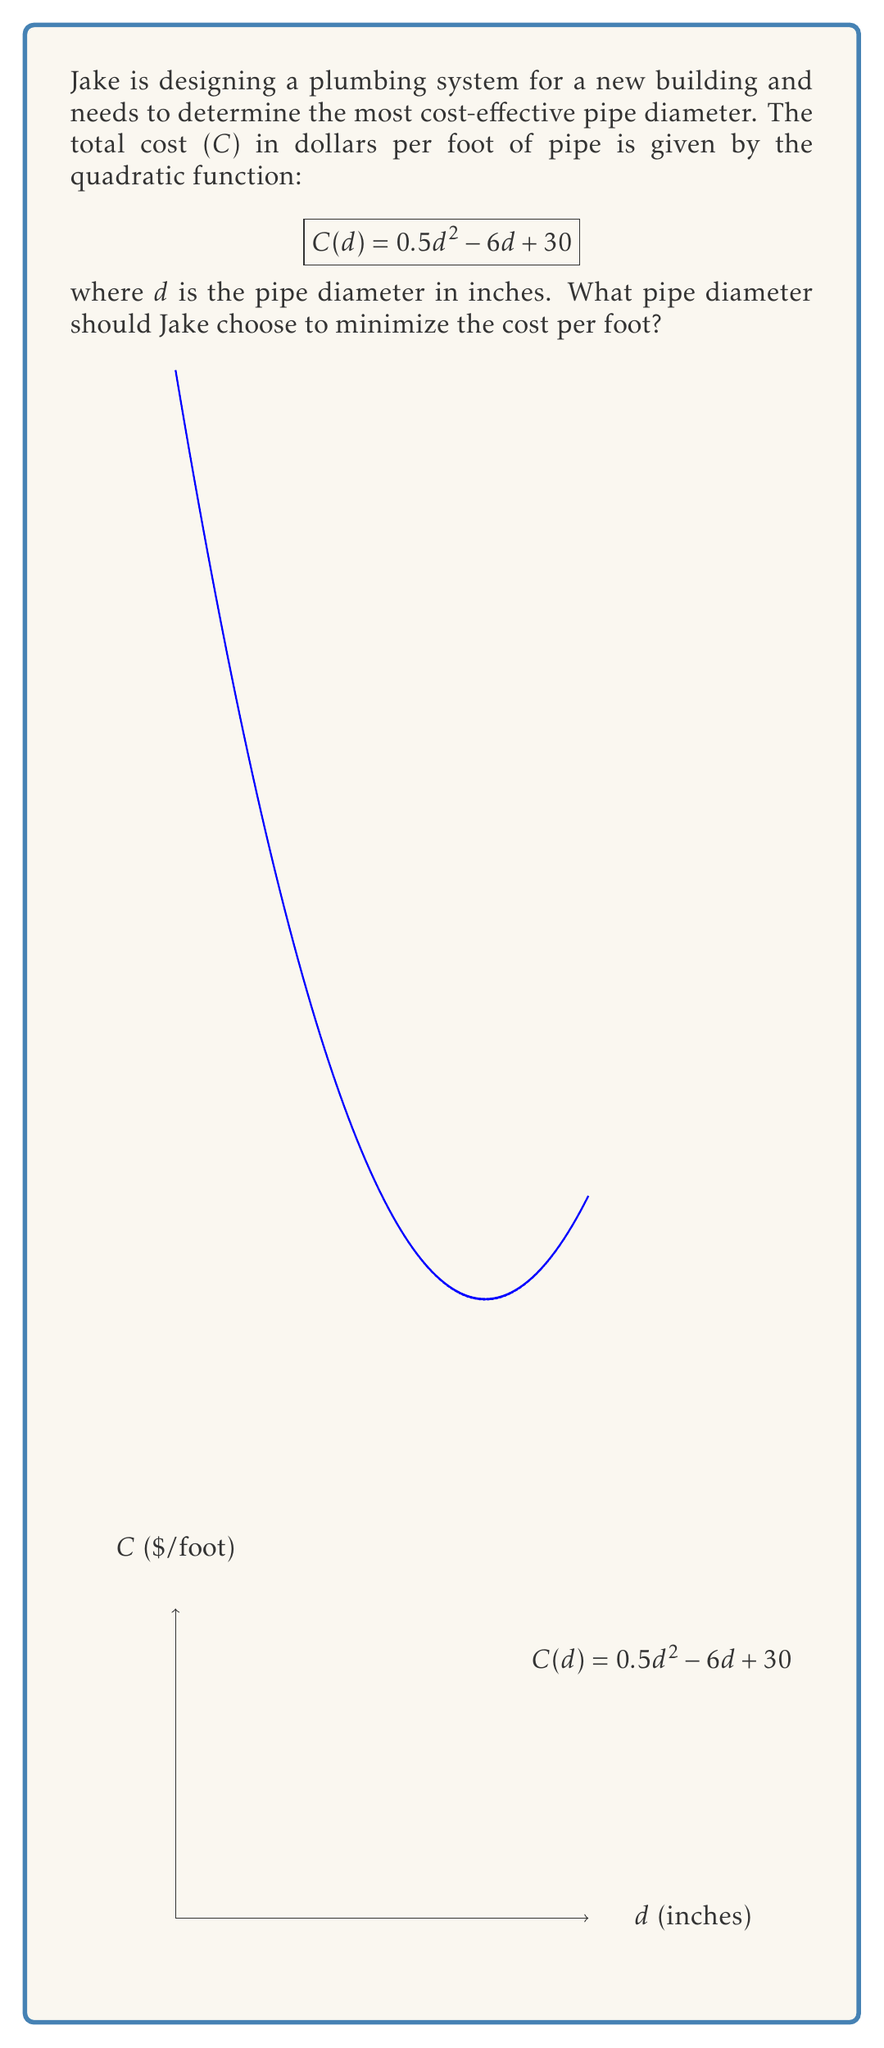Can you answer this question? To find the minimum cost, we need to determine the vertex of the quadratic function. For a quadratic function in the form $f(x) = ax^2 + bx + c$, the x-coordinate of the vertex is given by $x = -\frac{b}{2a}$.

1) Identify $a$, $b$, and $c$ from the given function:
   $C(d) = 0.5d^2 - 6d + 30$
   $a = 0.5$, $b = -6$, $c = 30$

2) Calculate the d-coordinate of the vertex:
   $d = -\frac{b}{2a} = -\frac{-6}{2(0.5)} = \frac{6}{1} = 6$

3) The d-coordinate of the vertex represents the pipe diameter that minimizes the cost.

4) To verify, we can calculate the second derivative:
   $C'(d) = d - 6$
   $C''(d) = 1$
   Since $C''(d)$ is positive, this confirms that $d = 6$ gives a minimum, not a maximum.

5) Therefore, Jake should choose a pipe diameter of 6 inches to minimize the cost per foot.
Answer: 6 inches 